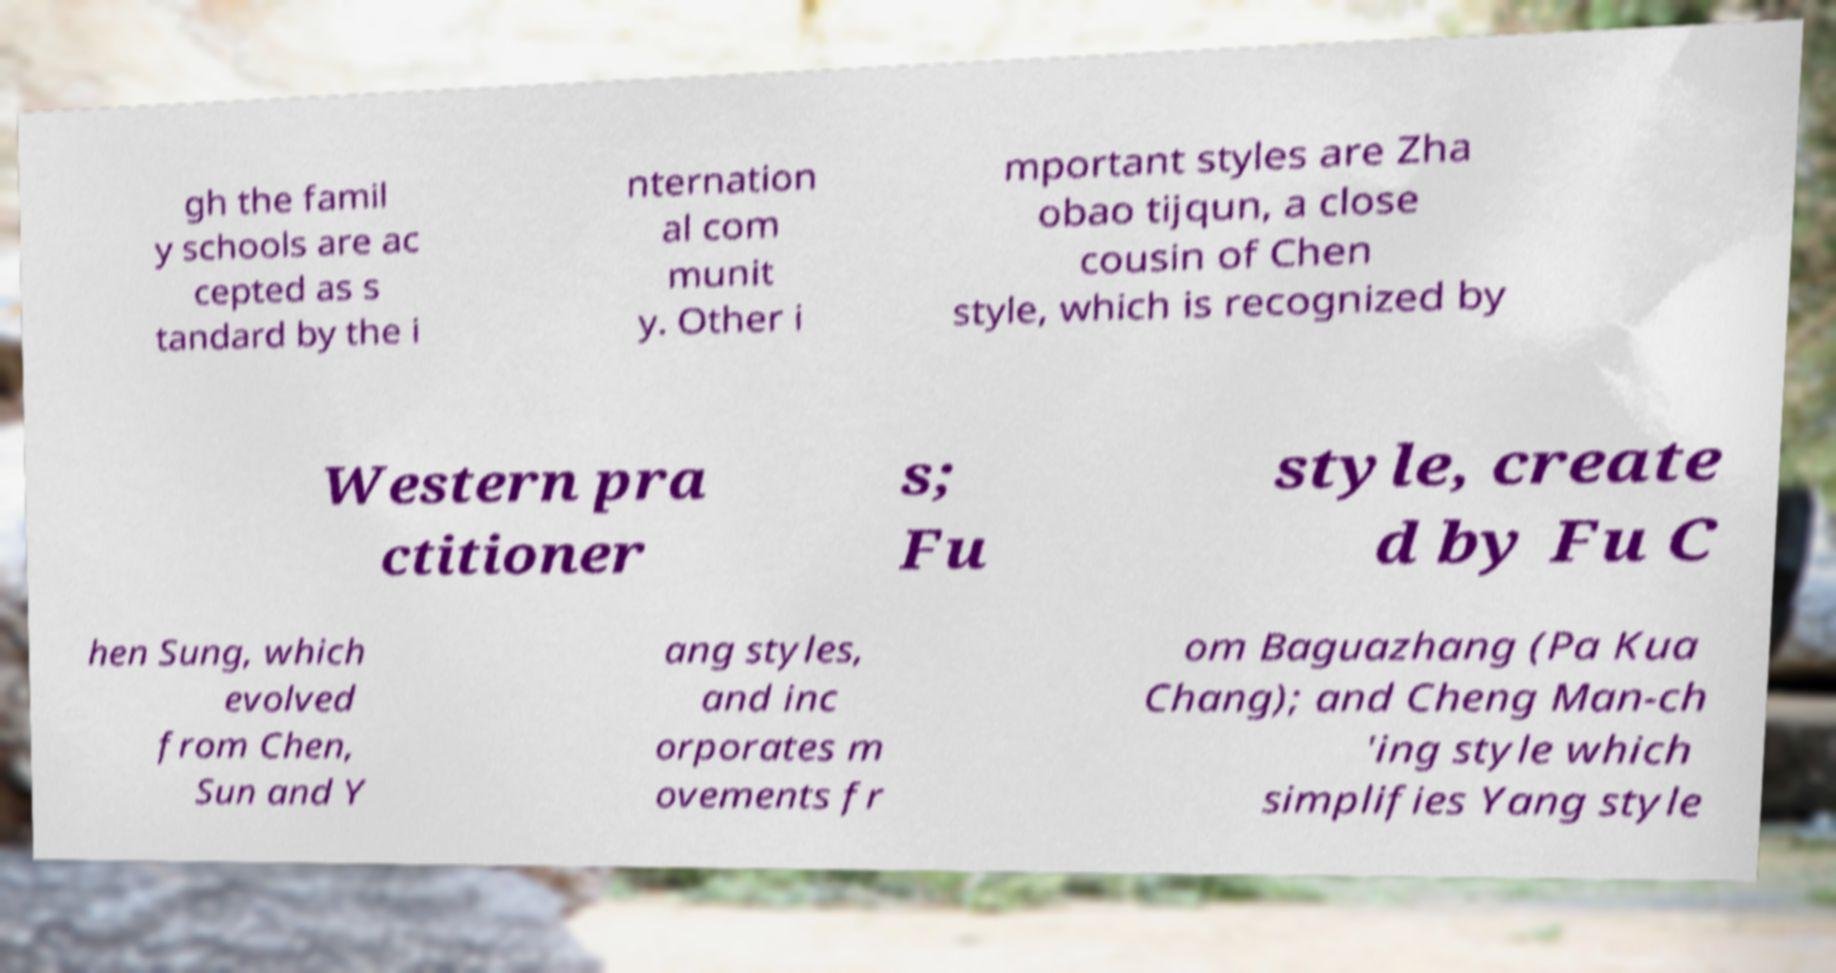Please read and relay the text visible in this image. What does it say? gh the famil y schools are ac cepted as s tandard by the i nternation al com munit y. Other i mportant styles are Zha obao tijqun, a close cousin of Chen style, which is recognized by Western pra ctitioner s; Fu style, create d by Fu C hen Sung, which evolved from Chen, Sun and Y ang styles, and inc orporates m ovements fr om Baguazhang (Pa Kua Chang); and Cheng Man-ch 'ing style which simplifies Yang style 